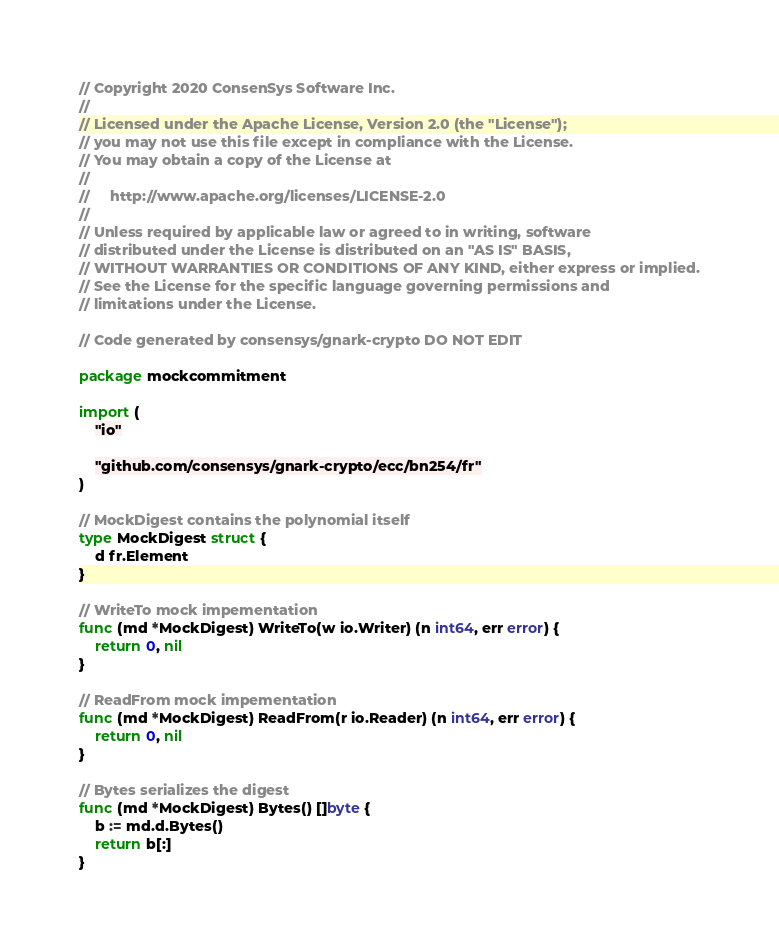<code> <loc_0><loc_0><loc_500><loc_500><_Go_>// Copyright 2020 ConsenSys Software Inc.
//
// Licensed under the Apache License, Version 2.0 (the "License");
// you may not use this file except in compliance with the License.
// You may obtain a copy of the License at
//
//     http://www.apache.org/licenses/LICENSE-2.0
//
// Unless required by applicable law or agreed to in writing, software
// distributed under the License is distributed on an "AS IS" BASIS,
// WITHOUT WARRANTIES OR CONDITIONS OF ANY KIND, either express or implied.
// See the License for the specific language governing permissions and
// limitations under the License.

// Code generated by consensys/gnark-crypto DO NOT EDIT

package mockcommitment

import (
	"io"

	"github.com/consensys/gnark-crypto/ecc/bn254/fr"
)

// MockDigest contains the polynomial itself
type MockDigest struct {
	d fr.Element
}

// WriteTo mock impementation
func (md *MockDigest) WriteTo(w io.Writer) (n int64, err error) {
	return 0, nil
}

// ReadFrom mock impementation
func (md *MockDigest) ReadFrom(r io.Reader) (n int64, err error) {
	return 0, nil
}

// Bytes serializes the digest
func (md *MockDigest) Bytes() []byte {
	b := md.d.Bytes()
	return b[:]
}
</code> 